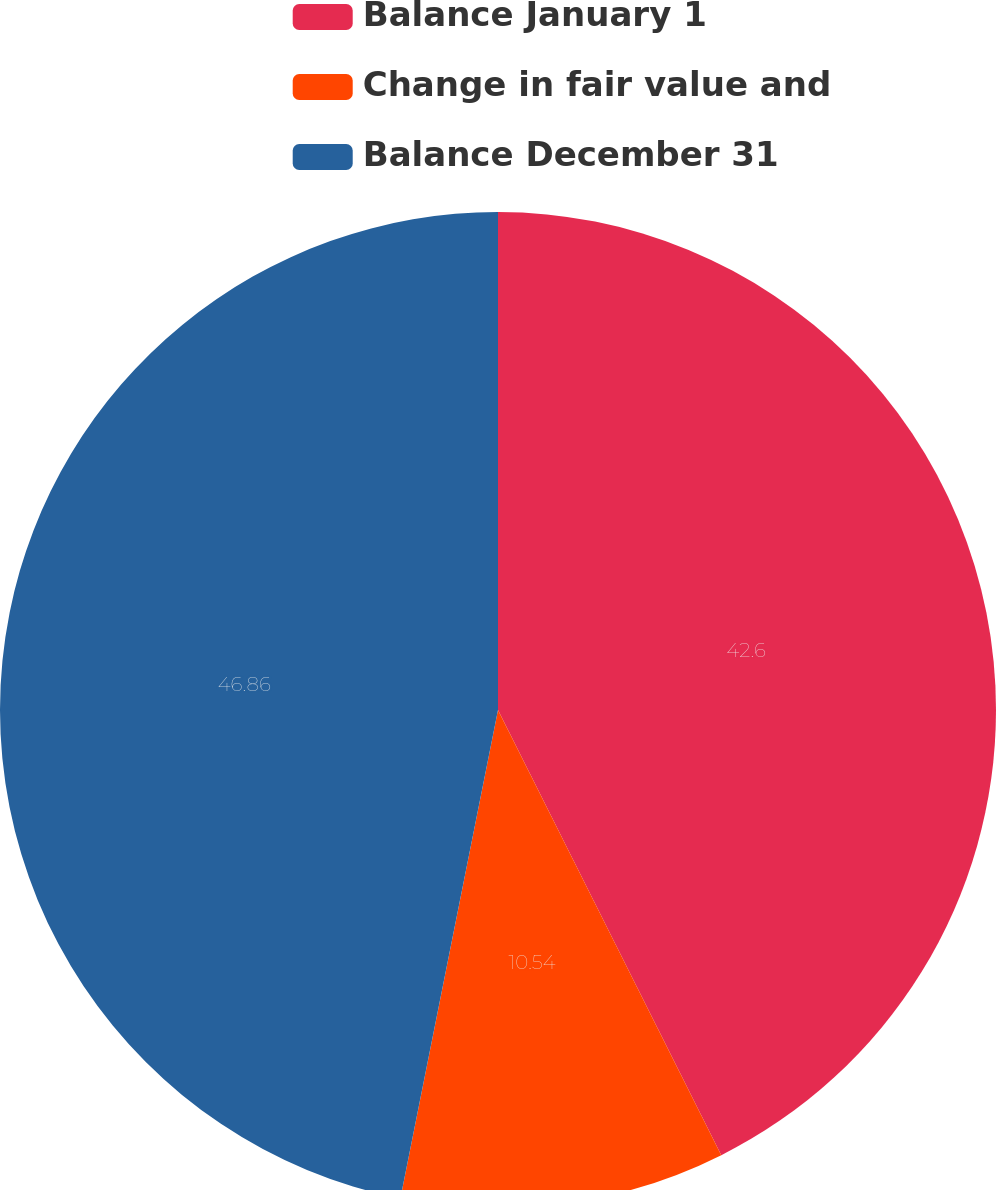Convert chart to OTSL. <chart><loc_0><loc_0><loc_500><loc_500><pie_chart><fcel>Balance January 1<fcel>Change in fair value and<fcel>Balance December 31<nl><fcel>42.6%<fcel>10.54%<fcel>46.86%<nl></chart> 